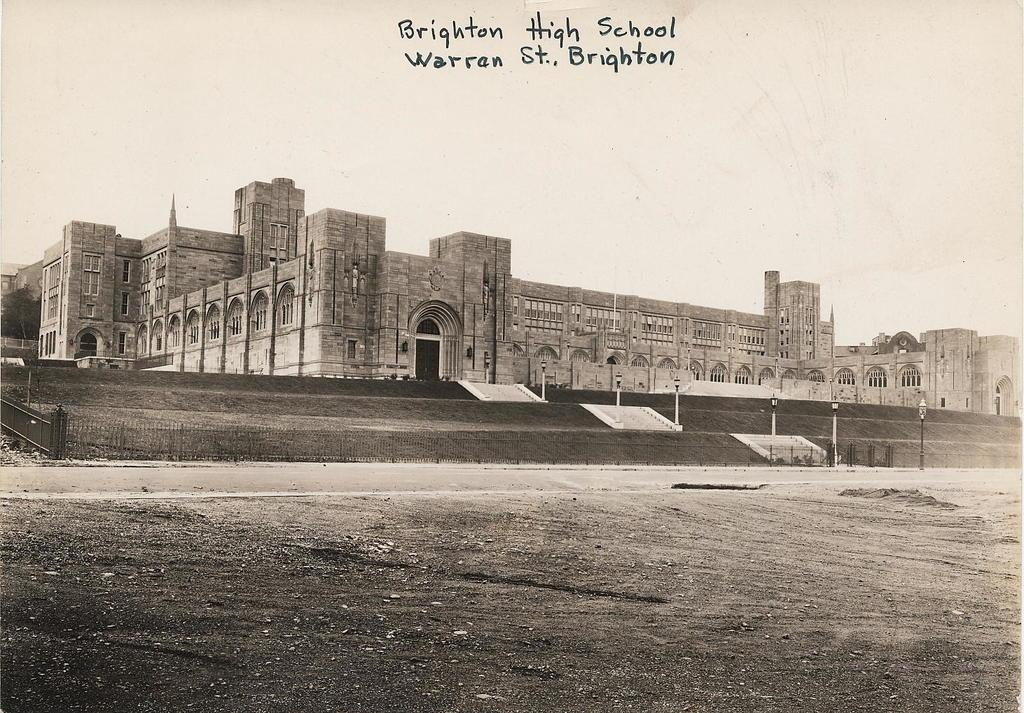<image>
Give a short and clear explanation of the subsequent image. A black and white photograph of a multi-story building with a writing that reads Brighton High School Warren St., Brighten. 